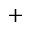Convert formula to latex. <formula><loc_0><loc_0><loc_500><loc_500>+</formula> 